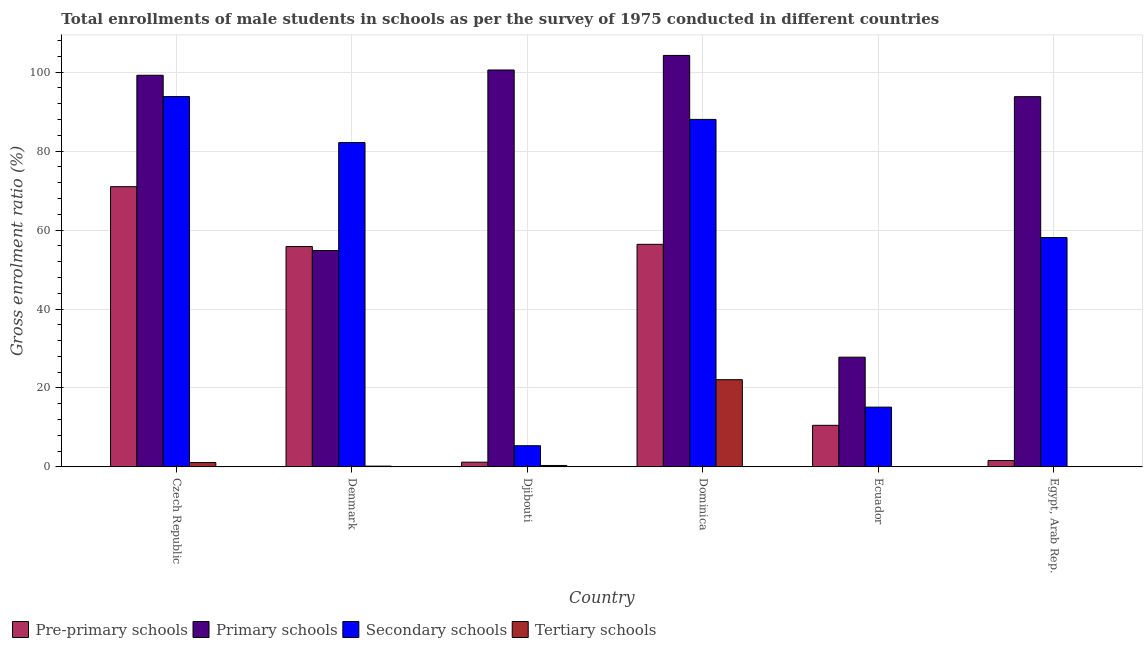How many groups of bars are there?
Ensure brevity in your answer.  6. Are the number of bars per tick equal to the number of legend labels?
Ensure brevity in your answer.  Yes. Are the number of bars on each tick of the X-axis equal?
Ensure brevity in your answer.  Yes. How many bars are there on the 6th tick from the left?
Provide a short and direct response. 4. How many bars are there on the 4th tick from the right?
Provide a succinct answer. 4. What is the label of the 6th group of bars from the left?
Provide a succinct answer. Egypt, Arab Rep. In how many cases, is the number of bars for a given country not equal to the number of legend labels?
Keep it short and to the point. 0. What is the gross enrolment ratio(male) in secondary schools in Ecuador?
Give a very brief answer. 15.14. Across all countries, what is the maximum gross enrolment ratio(male) in primary schools?
Provide a succinct answer. 104.23. Across all countries, what is the minimum gross enrolment ratio(male) in secondary schools?
Your answer should be very brief. 5.37. In which country was the gross enrolment ratio(male) in secondary schools maximum?
Give a very brief answer. Czech Republic. In which country was the gross enrolment ratio(male) in primary schools minimum?
Provide a short and direct response. Ecuador. What is the total gross enrolment ratio(male) in secondary schools in the graph?
Provide a short and direct response. 342.6. What is the difference between the gross enrolment ratio(male) in pre-primary schools in Czech Republic and that in Dominica?
Your answer should be compact. 14.6. What is the difference between the gross enrolment ratio(male) in secondary schools in Denmark and the gross enrolment ratio(male) in pre-primary schools in Egypt, Arab Rep.?
Offer a terse response. 80.54. What is the average gross enrolment ratio(male) in primary schools per country?
Make the answer very short. 80.06. What is the difference between the gross enrolment ratio(male) in tertiary schools and gross enrolment ratio(male) in primary schools in Denmark?
Ensure brevity in your answer.  -54.61. What is the ratio of the gross enrolment ratio(male) in tertiary schools in Czech Republic to that in Ecuador?
Your answer should be very brief. 27.06. What is the difference between the highest and the second highest gross enrolment ratio(male) in tertiary schools?
Your response must be concise. 20.98. What is the difference between the highest and the lowest gross enrolment ratio(male) in primary schools?
Make the answer very short. 76.43. Is the sum of the gross enrolment ratio(male) in secondary schools in Czech Republic and Dominica greater than the maximum gross enrolment ratio(male) in pre-primary schools across all countries?
Your answer should be compact. Yes. Is it the case that in every country, the sum of the gross enrolment ratio(male) in tertiary schools and gross enrolment ratio(male) in primary schools is greater than the sum of gross enrolment ratio(male) in secondary schools and gross enrolment ratio(male) in pre-primary schools?
Your response must be concise. No. What does the 2nd bar from the left in Ecuador represents?
Offer a terse response. Primary schools. What does the 3rd bar from the right in Dominica represents?
Ensure brevity in your answer.  Primary schools. How many countries are there in the graph?
Your response must be concise. 6. What is the difference between two consecutive major ticks on the Y-axis?
Your answer should be very brief. 20. Are the values on the major ticks of Y-axis written in scientific E-notation?
Provide a succinct answer. No. Does the graph contain grids?
Provide a short and direct response. Yes. How many legend labels are there?
Offer a very short reply. 4. How are the legend labels stacked?
Make the answer very short. Horizontal. What is the title of the graph?
Provide a succinct answer. Total enrollments of male students in schools as per the survey of 1975 conducted in different countries. Does "Finland" appear as one of the legend labels in the graph?
Keep it short and to the point. No. What is the label or title of the Y-axis?
Provide a short and direct response. Gross enrolment ratio (%). What is the Gross enrolment ratio (%) in Pre-primary schools in Czech Republic?
Your response must be concise. 70.99. What is the Gross enrolment ratio (%) in Primary schools in Czech Republic?
Make the answer very short. 99.21. What is the Gross enrolment ratio (%) in Secondary schools in Czech Republic?
Your answer should be very brief. 93.81. What is the Gross enrolment ratio (%) in Tertiary schools in Czech Republic?
Provide a short and direct response. 1.12. What is the Gross enrolment ratio (%) of Pre-primary schools in Denmark?
Keep it short and to the point. 55.83. What is the Gross enrolment ratio (%) in Primary schools in Denmark?
Offer a very short reply. 54.82. What is the Gross enrolment ratio (%) in Secondary schools in Denmark?
Your answer should be compact. 82.16. What is the Gross enrolment ratio (%) of Tertiary schools in Denmark?
Your answer should be very brief. 0.21. What is the Gross enrolment ratio (%) in Pre-primary schools in Djibouti?
Provide a succinct answer. 1.2. What is the Gross enrolment ratio (%) of Primary schools in Djibouti?
Keep it short and to the point. 100.54. What is the Gross enrolment ratio (%) of Secondary schools in Djibouti?
Make the answer very short. 5.37. What is the Gross enrolment ratio (%) in Tertiary schools in Djibouti?
Your response must be concise. 0.37. What is the Gross enrolment ratio (%) in Pre-primary schools in Dominica?
Offer a terse response. 56.39. What is the Gross enrolment ratio (%) of Primary schools in Dominica?
Provide a short and direct response. 104.23. What is the Gross enrolment ratio (%) of Secondary schools in Dominica?
Your response must be concise. 88.03. What is the Gross enrolment ratio (%) of Tertiary schools in Dominica?
Your answer should be very brief. 22.1. What is the Gross enrolment ratio (%) in Pre-primary schools in Ecuador?
Provide a succinct answer. 10.54. What is the Gross enrolment ratio (%) of Primary schools in Ecuador?
Your response must be concise. 27.8. What is the Gross enrolment ratio (%) in Secondary schools in Ecuador?
Offer a very short reply. 15.14. What is the Gross enrolment ratio (%) in Tertiary schools in Ecuador?
Give a very brief answer. 0.04. What is the Gross enrolment ratio (%) of Pre-primary schools in Egypt, Arab Rep.?
Provide a succinct answer. 1.61. What is the Gross enrolment ratio (%) in Primary schools in Egypt, Arab Rep.?
Provide a succinct answer. 93.79. What is the Gross enrolment ratio (%) of Secondary schools in Egypt, Arab Rep.?
Make the answer very short. 58.09. What is the Gross enrolment ratio (%) of Tertiary schools in Egypt, Arab Rep.?
Give a very brief answer. 0.05. Across all countries, what is the maximum Gross enrolment ratio (%) of Pre-primary schools?
Give a very brief answer. 70.99. Across all countries, what is the maximum Gross enrolment ratio (%) of Primary schools?
Your answer should be compact. 104.23. Across all countries, what is the maximum Gross enrolment ratio (%) in Secondary schools?
Offer a terse response. 93.81. Across all countries, what is the maximum Gross enrolment ratio (%) of Tertiary schools?
Offer a terse response. 22.1. Across all countries, what is the minimum Gross enrolment ratio (%) of Pre-primary schools?
Give a very brief answer. 1.2. Across all countries, what is the minimum Gross enrolment ratio (%) of Primary schools?
Offer a very short reply. 27.8. Across all countries, what is the minimum Gross enrolment ratio (%) in Secondary schools?
Provide a succinct answer. 5.37. Across all countries, what is the minimum Gross enrolment ratio (%) of Tertiary schools?
Offer a very short reply. 0.04. What is the total Gross enrolment ratio (%) of Pre-primary schools in the graph?
Offer a very short reply. 196.56. What is the total Gross enrolment ratio (%) of Primary schools in the graph?
Your answer should be very brief. 480.38. What is the total Gross enrolment ratio (%) of Secondary schools in the graph?
Ensure brevity in your answer.  342.6. What is the total Gross enrolment ratio (%) in Tertiary schools in the graph?
Offer a very short reply. 23.89. What is the difference between the Gross enrolment ratio (%) in Pre-primary schools in Czech Republic and that in Denmark?
Your answer should be very brief. 15.16. What is the difference between the Gross enrolment ratio (%) in Primary schools in Czech Republic and that in Denmark?
Provide a succinct answer. 44.4. What is the difference between the Gross enrolment ratio (%) of Secondary schools in Czech Republic and that in Denmark?
Give a very brief answer. 11.65. What is the difference between the Gross enrolment ratio (%) of Tertiary schools in Czech Republic and that in Denmark?
Ensure brevity in your answer.  0.91. What is the difference between the Gross enrolment ratio (%) in Pre-primary schools in Czech Republic and that in Djibouti?
Provide a short and direct response. 69.78. What is the difference between the Gross enrolment ratio (%) of Primary schools in Czech Republic and that in Djibouti?
Offer a very short reply. -1.33. What is the difference between the Gross enrolment ratio (%) of Secondary schools in Czech Republic and that in Djibouti?
Give a very brief answer. 88.43. What is the difference between the Gross enrolment ratio (%) of Tertiary schools in Czech Republic and that in Djibouti?
Give a very brief answer. 0.75. What is the difference between the Gross enrolment ratio (%) in Pre-primary schools in Czech Republic and that in Dominica?
Your response must be concise. 14.6. What is the difference between the Gross enrolment ratio (%) in Primary schools in Czech Republic and that in Dominica?
Provide a short and direct response. -5.02. What is the difference between the Gross enrolment ratio (%) of Secondary schools in Czech Republic and that in Dominica?
Your response must be concise. 5.78. What is the difference between the Gross enrolment ratio (%) in Tertiary schools in Czech Republic and that in Dominica?
Provide a succinct answer. -20.98. What is the difference between the Gross enrolment ratio (%) in Pre-primary schools in Czech Republic and that in Ecuador?
Ensure brevity in your answer.  60.45. What is the difference between the Gross enrolment ratio (%) of Primary schools in Czech Republic and that in Ecuador?
Your answer should be compact. 71.41. What is the difference between the Gross enrolment ratio (%) of Secondary schools in Czech Republic and that in Ecuador?
Offer a terse response. 78.66. What is the difference between the Gross enrolment ratio (%) of Tertiary schools in Czech Republic and that in Ecuador?
Your answer should be compact. 1.08. What is the difference between the Gross enrolment ratio (%) in Pre-primary schools in Czech Republic and that in Egypt, Arab Rep.?
Ensure brevity in your answer.  69.37. What is the difference between the Gross enrolment ratio (%) of Primary schools in Czech Republic and that in Egypt, Arab Rep.?
Provide a short and direct response. 5.42. What is the difference between the Gross enrolment ratio (%) in Secondary schools in Czech Republic and that in Egypt, Arab Rep.?
Your answer should be compact. 35.71. What is the difference between the Gross enrolment ratio (%) of Tertiary schools in Czech Republic and that in Egypt, Arab Rep.?
Keep it short and to the point. 1.06. What is the difference between the Gross enrolment ratio (%) in Pre-primary schools in Denmark and that in Djibouti?
Provide a short and direct response. 54.63. What is the difference between the Gross enrolment ratio (%) in Primary schools in Denmark and that in Djibouti?
Provide a short and direct response. -45.73. What is the difference between the Gross enrolment ratio (%) in Secondary schools in Denmark and that in Djibouti?
Provide a short and direct response. 76.78. What is the difference between the Gross enrolment ratio (%) in Tertiary schools in Denmark and that in Djibouti?
Make the answer very short. -0.16. What is the difference between the Gross enrolment ratio (%) in Pre-primary schools in Denmark and that in Dominica?
Provide a succinct answer. -0.56. What is the difference between the Gross enrolment ratio (%) in Primary schools in Denmark and that in Dominica?
Give a very brief answer. -49.41. What is the difference between the Gross enrolment ratio (%) of Secondary schools in Denmark and that in Dominica?
Ensure brevity in your answer.  -5.87. What is the difference between the Gross enrolment ratio (%) in Tertiary schools in Denmark and that in Dominica?
Offer a very short reply. -21.89. What is the difference between the Gross enrolment ratio (%) of Pre-primary schools in Denmark and that in Ecuador?
Make the answer very short. 45.29. What is the difference between the Gross enrolment ratio (%) of Primary schools in Denmark and that in Ecuador?
Ensure brevity in your answer.  27.02. What is the difference between the Gross enrolment ratio (%) in Secondary schools in Denmark and that in Ecuador?
Ensure brevity in your answer.  67.01. What is the difference between the Gross enrolment ratio (%) of Tertiary schools in Denmark and that in Ecuador?
Make the answer very short. 0.17. What is the difference between the Gross enrolment ratio (%) in Pre-primary schools in Denmark and that in Egypt, Arab Rep.?
Make the answer very short. 54.21. What is the difference between the Gross enrolment ratio (%) in Primary schools in Denmark and that in Egypt, Arab Rep.?
Provide a short and direct response. -38.97. What is the difference between the Gross enrolment ratio (%) of Secondary schools in Denmark and that in Egypt, Arab Rep.?
Your response must be concise. 24.06. What is the difference between the Gross enrolment ratio (%) of Tertiary schools in Denmark and that in Egypt, Arab Rep.?
Offer a terse response. 0.15. What is the difference between the Gross enrolment ratio (%) of Pre-primary schools in Djibouti and that in Dominica?
Your answer should be compact. -55.18. What is the difference between the Gross enrolment ratio (%) of Primary schools in Djibouti and that in Dominica?
Your answer should be very brief. -3.68. What is the difference between the Gross enrolment ratio (%) of Secondary schools in Djibouti and that in Dominica?
Give a very brief answer. -82.66. What is the difference between the Gross enrolment ratio (%) of Tertiary schools in Djibouti and that in Dominica?
Ensure brevity in your answer.  -21.73. What is the difference between the Gross enrolment ratio (%) of Pre-primary schools in Djibouti and that in Ecuador?
Keep it short and to the point. -9.34. What is the difference between the Gross enrolment ratio (%) of Primary schools in Djibouti and that in Ecuador?
Make the answer very short. 72.74. What is the difference between the Gross enrolment ratio (%) of Secondary schools in Djibouti and that in Ecuador?
Offer a very short reply. -9.77. What is the difference between the Gross enrolment ratio (%) in Tertiary schools in Djibouti and that in Ecuador?
Ensure brevity in your answer.  0.33. What is the difference between the Gross enrolment ratio (%) of Pre-primary schools in Djibouti and that in Egypt, Arab Rep.?
Your response must be concise. -0.41. What is the difference between the Gross enrolment ratio (%) of Primary schools in Djibouti and that in Egypt, Arab Rep.?
Offer a terse response. 6.76. What is the difference between the Gross enrolment ratio (%) of Secondary schools in Djibouti and that in Egypt, Arab Rep.?
Ensure brevity in your answer.  -52.72. What is the difference between the Gross enrolment ratio (%) in Tertiary schools in Djibouti and that in Egypt, Arab Rep.?
Give a very brief answer. 0.32. What is the difference between the Gross enrolment ratio (%) in Pre-primary schools in Dominica and that in Ecuador?
Offer a very short reply. 45.85. What is the difference between the Gross enrolment ratio (%) in Primary schools in Dominica and that in Ecuador?
Ensure brevity in your answer.  76.43. What is the difference between the Gross enrolment ratio (%) of Secondary schools in Dominica and that in Ecuador?
Your response must be concise. 72.88. What is the difference between the Gross enrolment ratio (%) in Tertiary schools in Dominica and that in Ecuador?
Your answer should be very brief. 22.06. What is the difference between the Gross enrolment ratio (%) of Pre-primary schools in Dominica and that in Egypt, Arab Rep.?
Provide a succinct answer. 54.77. What is the difference between the Gross enrolment ratio (%) of Primary schools in Dominica and that in Egypt, Arab Rep.?
Make the answer very short. 10.44. What is the difference between the Gross enrolment ratio (%) of Secondary schools in Dominica and that in Egypt, Arab Rep.?
Make the answer very short. 29.94. What is the difference between the Gross enrolment ratio (%) in Tertiary schools in Dominica and that in Egypt, Arab Rep.?
Provide a succinct answer. 22.05. What is the difference between the Gross enrolment ratio (%) in Pre-primary schools in Ecuador and that in Egypt, Arab Rep.?
Your answer should be very brief. 8.93. What is the difference between the Gross enrolment ratio (%) of Primary schools in Ecuador and that in Egypt, Arab Rep.?
Offer a very short reply. -65.99. What is the difference between the Gross enrolment ratio (%) in Secondary schools in Ecuador and that in Egypt, Arab Rep.?
Offer a terse response. -42.95. What is the difference between the Gross enrolment ratio (%) in Tertiary schools in Ecuador and that in Egypt, Arab Rep.?
Ensure brevity in your answer.  -0.01. What is the difference between the Gross enrolment ratio (%) in Pre-primary schools in Czech Republic and the Gross enrolment ratio (%) in Primary schools in Denmark?
Give a very brief answer. 16.17. What is the difference between the Gross enrolment ratio (%) in Pre-primary schools in Czech Republic and the Gross enrolment ratio (%) in Secondary schools in Denmark?
Provide a short and direct response. -11.17. What is the difference between the Gross enrolment ratio (%) in Pre-primary schools in Czech Republic and the Gross enrolment ratio (%) in Tertiary schools in Denmark?
Your answer should be very brief. 70.78. What is the difference between the Gross enrolment ratio (%) in Primary schools in Czech Republic and the Gross enrolment ratio (%) in Secondary schools in Denmark?
Make the answer very short. 17.06. What is the difference between the Gross enrolment ratio (%) in Primary schools in Czech Republic and the Gross enrolment ratio (%) in Tertiary schools in Denmark?
Offer a terse response. 99. What is the difference between the Gross enrolment ratio (%) in Secondary schools in Czech Republic and the Gross enrolment ratio (%) in Tertiary schools in Denmark?
Give a very brief answer. 93.6. What is the difference between the Gross enrolment ratio (%) of Pre-primary schools in Czech Republic and the Gross enrolment ratio (%) of Primary schools in Djibouti?
Provide a succinct answer. -29.56. What is the difference between the Gross enrolment ratio (%) of Pre-primary schools in Czech Republic and the Gross enrolment ratio (%) of Secondary schools in Djibouti?
Offer a very short reply. 65.61. What is the difference between the Gross enrolment ratio (%) in Pre-primary schools in Czech Republic and the Gross enrolment ratio (%) in Tertiary schools in Djibouti?
Your response must be concise. 70.62. What is the difference between the Gross enrolment ratio (%) in Primary schools in Czech Republic and the Gross enrolment ratio (%) in Secondary schools in Djibouti?
Your answer should be very brief. 93.84. What is the difference between the Gross enrolment ratio (%) of Primary schools in Czech Republic and the Gross enrolment ratio (%) of Tertiary schools in Djibouti?
Provide a short and direct response. 98.84. What is the difference between the Gross enrolment ratio (%) of Secondary schools in Czech Republic and the Gross enrolment ratio (%) of Tertiary schools in Djibouti?
Keep it short and to the point. 93.44. What is the difference between the Gross enrolment ratio (%) of Pre-primary schools in Czech Republic and the Gross enrolment ratio (%) of Primary schools in Dominica?
Provide a succinct answer. -33.24. What is the difference between the Gross enrolment ratio (%) in Pre-primary schools in Czech Republic and the Gross enrolment ratio (%) in Secondary schools in Dominica?
Ensure brevity in your answer.  -17.04. What is the difference between the Gross enrolment ratio (%) in Pre-primary schools in Czech Republic and the Gross enrolment ratio (%) in Tertiary schools in Dominica?
Your response must be concise. 48.89. What is the difference between the Gross enrolment ratio (%) in Primary schools in Czech Republic and the Gross enrolment ratio (%) in Secondary schools in Dominica?
Your answer should be very brief. 11.18. What is the difference between the Gross enrolment ratio (%) of Primary schools in Czech Republic and the Gross enrolment ratio (%) of Tertiary schools in Dominica?
Make the answer very short. 77.11. What is the difference between the Gross enrolment ratio (%) of Secondary schools in Czech Republic and the Gross enrolment ratio (%) of Tertiary schools in Dominica?
Your answer should be very brief. 71.71. What is the difference between the Gross enrolment ratio (%) in Pre-primary schools in Czech Republic and the Gross enrolment ratio (%) in Primary schools in Ecuador?
Your answer should be compact. 43.19. What is the difference between the Gross enrolment ratio (%) in Pre-primary schools in Czech Republic and the Gross enrolment ratio (%) in Secondary schools in Ecuador?
Offer a very short reply. 55.84. What is the difference between the Gross enrolment ratio (%) in Pre-primary schools in Czech Republic and the Gross enrolment ratio (%) in Tertiary schools in Ecuador?
Keep it short and to the point. 70.94. What is the difference between the Gross enrolment ratio (%) of Primary schools in Czech Republic and the Gross enrolment ratio (%) of Secondary schools in Ecuador?
Offer a terse response. 84.07. What is the difference between the Gross enrolment ratio (%) in Primary schools in Czech Republic and the Gross enrolment ratio (%) in Tertiary schools in Ecuador?
Give a very brief answer. 99.17. What is the difference between the Gross enrolment ratio (%) of Secondary schools in Czech Republic and the Gross enrolment ratio (%) of Tertiary schools in Ecuador?
Give a very brief answer. 93.76. What is the difference between the Gross enrolment ratio (%) in Pre-primary schools in Czech Republic and the Gross enrolment ratio (%) in Primary schools in Egypt, Arab Rep.?
Make the answer very short. -22.8. What is the difference between the Gross enrolment ratio (%) of Pre-primary schools in Czech Republic and the Gross enrolment ratio (%) of Secondary schools in Egypt, Arab Rep.?
Your response must be concise. 12.89. What is the difference between the Gross enrolment ratio (%) in Pre-primary schools in Czech Republic and the Gross enrolment ratio (%) in Tertiary schools in Egypt, Arab Rep.?
Provide a short and direct response. 70.93. What is the difference between the Gross enrolment ratio (%) of Primary schools in Czech Republic and the Gross enrolment ratio (%) of Secondary schools in Egypt, Arab Rep.?
Provide a succinct answer. 41.12. What is the difference between the Gross enrolment ratio (%) of Primary schools in Czech Republic and the Gross enrolment ratio (%) of Tertiary schools in Egypt, Arab Rep.?
Your answer should be compact. 99.16. What is the difference between the Gross enrolment ratio (%) of Secondary schools in Czech Republic and the Gross enrolment ratio (%) of Tertiary schools in Egypt, Arab Rep.?
Offer a very short reply. 93.75. What is the difference between the Gross enrolment ratio (%) of Pre-primary schools in Denmark and the Gross enrolment ratio (%) of Primary schools in Djibouti?
Offer a very short reply. -44.72. What is the difference between the Gross enrolment ratio (%) in Pre-primary schools in Denmark and the Gross enrolment ratio (%) in Secondary schools in Djibouti?
Ensure brevity in your answer.  50.46. What is the difference between the Gross enrolment ratio (%) in Pre-primary schools in Denmark and the Gross enrolment ratio (%) in Tertiary schools in Djibouti?
Provide a succinct answer. 55.46. What is the difference between the Gross enrolment ratio (%) of Primary schools in Denmark and the Gross enrolment ratio (%) of Secondary schools in Djibouti?
Your answer should be compact. 49.44. What is the difference between the Gross enrolment ratio (%) in Primary schools in Denmark and the Gross enrolment ratio (%) in Tertiary schools in Djibouti?
Keep it short and to the point. 54.45. What is the difference between the Gross enrolment ratio (%) of Secondary schools in Denmark and the Gross enrolment ratio (%) of Tertiary schools in Djibouti?
Provide a short and direct response. 81.79. What is the difference between the Gross enrolment ratio (%) of Pre-primary schools in Denmark and the Gross enrolment ratio (%) of Primary schools in Dominica?
Provide a succinct answer. -48.4. What is the difference between the Gross enrolment ratio (%) in Pre-primary schools in Denmark and the Gross enrolment ratio (%) in Secondary schools in Dominica?
Ensure brevity in your answer.  -32.2. What is the difference between the Gross enrolment ratio (%) in Pre-primary schools in Denmark and the Gross enrolment ratio (%) in Tertiary schools in Dominica?
Your response must be concise. 33.73. What is the difference between the Gross enrolment ratio (%) in Primary schools in Denmark and the Gross enrolment ratio (%) in Secondary schools in Dominica?
Give a very brief answer. -33.21. What is the difference between the Gross enrolment ratio (%) in Primary schools in Denmark and the Gross enrolment ratio (%) in Tertiary schools in Dominica?
Provide a short and direct response. 32.72. What is the difference between the Gross enrolment ratio (%) in Secondary schools in Denmark and the Gross enrolment ratio (%) in Tertiary schools in Dominica?
Your answer should be compact. 60.06. What is the difference between the Gross enrolment ratio (%) of Pre-primary schools in Denmark and the Gross enrolment ratio (%) of Primary schools in Ecuador?
Keep it short and to the point. 28.03. What is the difference between the Gross enrolment ratio (%) of Pre-primary schools in Denmark and the Gross enrolment ratio (%) of Secondary schools in Ecuador?
Offer a very short reply. 40.68. What is the difference between the Gross enrolment ratio (%) of Pre-primary schools in Denmark and the Gross enrolment ratio (%) of Tertiary schools in Ecuador?
Provide a short and direct response. 55.79. What is the difference between the Gross enrolment ratio (%) of Primary schools in Denmark and the Gross enrolment ratio (%) of Secondary schools in Ecuador?
Keep it short and to the point. 39.67. What is the difference between the Gross enrolment ratio (%) in Primary schools in Denmark and the Gross enrolment ratio (%) in Tertiary schools in Ecuador?
Your answer should be compact. 54.77. What is the difference between the Gross enrolment ratio (%) in Secondary schools in Denmark and the Gross enrolment ratio (%) in Tertiary schools in Ecuador?
Provide a short and direct response. 82.11. What is the difference between the Gross enrolment ratio (%) of Pre-primary schools in Denmark and the Gross enrolment ratio (%) of Primary schools in Egypt, Arab Rep.?
Your answer should be very brief. -37.96. What is the difference between the Gross enrolment ratio (%) of Pre-primary schools in Denmark and the Gross enrolment ratio (%) of Secondary schools in Egypt, Arab Rep.?
Your answer should be very brief. -2.26. What is the difference between the Gross enrolment ratio (%) of Pre-primary schools in Denmark and the Gross enrolment ratio (%) of Tertiary schools in Egypt, Arab Rep.?
Give a very brief answer. 55.77. What is the difference between the Gross enrolment ratio (%) of Primary schools in Denmark and the Gross enrolment ratio (%) of Secondary schools in Egypt, Arab Rep.?
Offer a very short reply. -3.28. What is the difference between the Gross enrolment ratio (%) in Primary schools in Denmark and the Gross enrolment ratio (%) in Tertiary schools in Egypt, Arab Rep.?
Offer a terse response. 54.76. What is the difference between the Gross enrolment ratio (%) in Secondary schools in Denmark and the Gross enrolment ratio (%) in Tertiary schools in Egypt, Arab Rep.?
Provide a short and direct response. 82.1. What is the difference between the Gross enrolment ratio (%) of Pre-primary schools in Djibouti and the Gross enrolment ratio (%) of Primary schools in Dominica?
Your answer should be very brief. -103.03. What is the difference between the Gross enrolment ratio (%) in Pre-primary schools in Djibouti and the Gross enrolment ratio (%) in Secondary schools in Dominica?
Your answer should be compact. -86.83. What is the difference between the Gross enrolment ratio (%) in Pre-primary schools in Djibouti and the Gross enrolment ratio (%) in Tertiary schools in Dominica?
Ensure brevity in your answer.  -20.9. What is the difference between the Gross enrolment ratio (%) of Primary schools in Djibouti and the Gross enrolment ratio (%) of Secondary schools in Dominica?
Provide a succinct answer. 12.52. What is the difference between the Gross enrolment ratio (%) in Primary schools in Djibouti and the Gross enrolment ratio (%) in Tertiary schools in Dominica?
Your answer should be very brief. 78.45. What is the difference between the Gross enrolment ratio (%) in Secondary schools in Djibouti and the Gross enrolment ratio (%) in Tertiary schools in Dominica?
Provide a succinct answer. -16.73. What is the difference between the Gross enrolment ratio (%) of Pre-primary schools in Djibouti and the Gross enrolment ratio (%) of Primary schools in Ecuador?
Provide a short and direct response. -26.6. What is the difference between the Gross enrolment ratio (%) of Pre-primary schools in Djibouti and the Gross enrolment ratio (%) of Secondary schools in Ecuador?
Your answer should be compact. -13.94. What is the difference between the Gross enrolment ratio (%) of Pre-primary schools in Djibouti and the Gross enrolment ratio (%) of Tertiary schools in Ecuador?
Your answer should be compact. 1.16. What is the difference between the Gross enrolment ratio (%) in Primary schools in Djibouti and the Gross enrolment ratio (%) in Secondary schools in Ecuador?
Ensure brevity in your answer.  85.4. What is the difference between the Gross enrolment ratio (%) of Primary schools in Djibouti and the Gross enrolment ratio (%) of Tertiary schools in Ecuador?
Your response must be concise. 100.5. What is the difference between the Gross enrolment ratio (%) in Secondary schools in Djibouti and the Gross enrolment ratio (%) in Tertiary schools in Ecuador?
Offer a very short reply. 5.33. What is the difference between the Gross enrolment ratio (%) in Pre-primary schools in Djibouti and the Gross enrolment ratio (%) in Primary schools in Egypt, Arab Rep.?
Your answer should be very brief. -92.59. What is the difference between the Gross enrolment ratio (%) of Pre-primary schools in Djibouti and the Gross enrolment ratio (%) of Secondary schools in Egypt, Arab Rep.?
Offer a terse response. -56.89. What is the difference between the Gross enrolment ratio (%) in Pre-primary schools in Djibouti and the Gross enrolment ratio (%) in Tertiary schools in Egypt, Arab Rep.?
Make the answer very short. 1.15. What is the difference between the Gross enrolment ratio (%) in Primary schools in Djibouti and the Gross enrolment ratio (%) in Secondary schools in Egypt, Arab Rep.?
Provide a short and direct response. 42.45. What is the difference between the Gross enrolment ratio (%) of Primary schools in Djibouti and the Gross enrolment ratio (%) of Tertiary schools in Egypt, Arab Rep.?
Your answer should be compact. 100.49. What is the difference between the Gross enrolment ratio (%) of Secondary schools in Djibouti and the Gross enrolment ratio (%) of Tertiary schools in Egypt, Arab Rep.?
Offer a very short reply. 5.32. What is the difference between the Gross enrolment ratio (%) of Pre-primary schools in Dominica and the Gross enrolment ratio (%) of Primary schools in Ecuador?
Your response must be concise. 28.59. What is the difference between the Gross enrolment ratio (%) of Pre-primary schools in Dominica and the Gross enrolment ratio (%) of Secondary schools in Ecuador?
Give a very brief answer. 41.24. What is the difference between the Gross enrolment ratio (%) of Pre-primary schools in Dominica and the Gross enrolment ratio (%) of Tertiary schools in Ecuador?
Your answer should be very brief. 56.34. What is the difference between the Gross enrolment ratio (%) in Primary schools in Dominica and the Gross enrolment ratio (%) in Secondary schools in Ecuador?
Offer a terse response. 89.08. What is the difference between the Gross enrolment ratio (%) of Primary schools in Dominica and the Gross enrolment ratio (%) of Tertiary schools in Ecuador?
Offer a very short reply. 104.19. What is the difference between the Gross enrolment ratio (%) in Secondary schools in Dominica and the Gross enrolment ratio (%) in Tertiary schools in Ecuador?
Offer a terse response. 87.99. What is the difference between the Gross enrolment ratio (%) of Pre-primary schools in Dominica and the Gross enrolment ratio (%) of Primary schools in Egypt, Arab Rep.?
Keep it short and to the point. -37.4. What is the difference between the Gross enrolment ratio (%) in Pre-primary schools in Dominica and the Gross enrolment ratio (%) in Secondary schools in Egypt, Arab Rep.?
Give a very brief answer. -1.71. What is the difference between the Gross enrolment ratio (%) in Pre-primary schools in Dominica and the Gross enrolment ratio (%) in Tertiary schools in Egypt, Arab Rep.?
Offer a terse response. 56.33. What is the difference between the Gross enrolment ratio (%) of Primary schools in Dominica and the Gross enrolment ratio (%) of Secondary schools in Egypt, Arab Rep.?
Your answer should be very brief. 46.14. What is the difference between the Gross enrolment ratio (%) in Primary schools in Dominica and the Gross enrolment ratio (%) in Tertiary schools in Egypt, Arab Rep.?
Give a very brief answer. 104.17. What is the difference between the Gross enrolment ratio (%) in Secondary schools in Dominica and the Gross enrolment ratio (%) in Tertiary schools in Egypt, Arab Rep.?
Ensure brevity in your answer.  87.97. What is the difference between the Gross enrolment ratio (%) of Pre-primary schools in Ecuador and the Gross enrolment ratio (%) of Primary schools in Egypt, Arab Rep.?
Your answer should be very brief. -83.25. What is the difference between the Gross enrolment ratio (%) of Pre-primary schools in Ecuador and the Gross enrolment ratio (%) of Secondary schools in Egypt, Arab Rep.?
Keep it short and to the point. -47.55. What is the difference between the Gross enrolment ratio (%) of Pre-primary schools in Ecuador and the Gross enrolment ratio (%) of Tertiary schools in Egypt, Arab Rep.?
Offer a very short reply. 10.49. What is the difference between the Gross enrolment ratio (%) of Primary schools in Ecuador and the Gross enrolment ratio (%) of Secondary schools in Egypt, Arab Rep.?
Keep it short and to the point. -30.29. What is the difference between the Gross enrolment ratio (%) in Primary schools in Ecuador and the Gross enrolment ratio (%) in Tertiary schools in Egypt, Arab Rep.?
Provide a succinct answer. 27.75. What is the difference between the Gross enrolment ratio (%) of Secondary schools in Ecuador and the Gross enrolment ratio (%) of Tertiary schools in Egypt, Arab Rep.?
Make the answer very short. 15.09. What is the average Gross enrolment ratio (%) of Pre-primary schools per country?
Keep it short and to the point. 32.76. What is the average Gross enrolment ratio (%) of Primary schools per country?
Make the answer very short. 80.06. What is the average Gross enrolment ratio (%) of Secondary schools per country?
Your answer should be compact. 57.1. What is the average Gross enrolment ratio (%) in Tertiary schools per country?
Your response must be concise. 3.98. What is the difference between the Gross enrolment ratio (%) in Pre-primary schools and Gross enrolment ratio (%) in Primary schools in Czech Republic?
Offer a very short reply. -28.23. What is the difference between the Gross enrolment ratio (%) of Pre-primary schools and Gross enrolment ratio (%) of Secondary schools in Czech Republic?
Your answer should be very brief. -22.82. What is the difference between the Gross enrolment ratio (%) of Pre-primary schools and Gross enrolment ratio (%) of Tertiary schools in Czech Republic?
Keep it short and to the point. 69.87. What is the difference between the Gross enrolment ratio (%) of Primary schools and Gross enrolment ratio (%) of Secondary schools in Czech Republic?
Make the answer very short. 5.41. What is the difference between the Gross enrolment ratio (%) of Primary schools and Gross enrolment ratio (%) of Tertiary schools in Czech Republic?
Keep it short and to the point. 98.09. What is the difference between the Gross enrolment ratio (%) in Secondary schools and Gross enrolment ratio (%) in Tertiary schools in Czech Republic?
Provide a succinct answer. 92.69. What is the difference between the Gross enrolment ratio (%) of Pre-primary schools and Gross enrolment ratio (%) of Primary schools in Denmark?
Your answer should be compact. 1.01. What is the difference between the Gross enrolment ratio (%) in Pre-primary schools and Gross enrolment ratio (%) in Secondary schools in Denmark?
Keep it short and to the point. -26.33. What is the difference between the Gross enrolment ratio (%) in Pre-primary schools and Gross enrolment ratio (%) in Tertiary schools in Denmark?
Ensure brevity in your answer.  55.62. What is the difference between the Gross enrolment ratio (%) in Primary schools and Gross enrolment ratio (%) in Secondary schools in Denmark?
Offer a terse response. -27.34. What is the difference between the Gross enrolment ratio (%) of Primary schools and Gross enrolment ratio (%) of Tertiary schools in Denmark?
Ensure brevity in your answer.  54.61. What is the difference between the Gross enrolment ratio (%) in Secondary schools and Gross enrolment ratio (%) in Tertiary schools in Denmark?
Offer a terse response. 81.95. What is the difference between the Gross enrolment ratio (%) of Pre-primary schools and Gross enrolment ratio (%) of Primary schools in Djibouti?
Keep it short and to the point. -99.34. What is the difference between the Gross enrolment ratio (%) in Pre-primary schools and Gross enrolment ratio (%) in Secondary schools in Djibouti?
Make the answer very short. -4.17. What is the difference between the Gross enrolment ratio (%) in Pre-primary schools and Gross enrolment ratio (%) in Tertiary schools in Djibouti?
Make the answer very short. 0.83. What is the difference between the Gross enrolment ratio (%) in Primary schools and Gross enrolment ratio (%) in Secondary schools in Djibouti?
Provide a succinct answer. 95.17. What is the difference between the Gross enrolment ratio (%) of Primary schools and Gross enrolment ratio (%) of Tertiary schools in Djibouti?
Your response must be concise. 100.18. What is the difference between the Gross enrolment ratio (%) in Secondary schools and Gross enrolment ratio (%) in Tertiary schools in Djibouti?
Provide a short and direct response. 5. What is the difference between the Gross enrolment ratio (%) of Pre-primary schools and Gross enrolment ratio (%) of Primary schools in Dominica?
Ensure brevity in your answer.  -47.84. What is the difference between the Gross enrolment ratio (%) of Pre-primary schools and Gross enrolment ratio (%) of Secondary schools in Dominica?
Provide a succinct answer. -31.64. What is the difference between the Gross enrolment ratio (%) in Pre-primary schools and Gross enrolment ratio (%) in Tertiary schools in Dominica?
Keep it short and to the point. 34.29. What is the difference between the Gross enrolment ratio (%) of Primary schools and Gross enrolment ratio (%) of Secondary schools in Dominica?
Your response must be concise. 16.2. What is the difference between the Gross enrolment ratio (%) of Primary schools and Gross enrolment ratio (%) of Tertiary schools in Dominica?
Your answer should be compact. 82.13. What is the difference between the Gross enrolment ratio (%) in Secondary schools and Gross enrolment ratio (%) in Tertiary schools in Dominica?
Provide a short and direct response. 65.93. What is the difference between the Gross enrolment ratio (%) of Pre-primary schools and Gross enrolment ratio (%) of Primary schools in Ecuador?
Offer a very short reply. -17.26. What is the difference between the Gross enrolment ratio (%) in Pre-primary schools and Gross enrolment ratio (%) in Secondary schools in Ecuador?
Give a very brief answer. -4.6. What is the difference between the Gross enrolment ratio (%) in Pre-primary schools and Gross enrolment ratio (%) in Tertiary schools in Ecuador?
Provide a short and direct response. 10.5. What is the difference between the Gross enrolment ratio (%) in Primary schools and Gross enrolment ratio (%) in Secondary schools in Ecuador?
Give a very brief answer. 12.66. What is the difference between the Gross enrolment ratio (%) of Primary schools and Gross enrolment ratio (%) of Tertiary schools in Ecuador?
Provide a short and direct response. 27.76. What is the difference between the Gross enrolment ratio (%) in Secondary schools and Gross enrolment ratio (%) in Tertiary schools in Ecuador?
Provide a short and direct response. 15.1. What is the difference between the Gross enrolment ratio (%) of Pre-primary schools and Gross enrolment ratio (%) of Primary schools in Egypt, Arab Rep.?
Offer a very short reply. -92.17. What is the difference between the Gross enrolment ratio (%) in Pre-primary schools and Gross enrolment ratio (%) in Secondary schools in Egypt, Arab Rep.?
Your answer should be very brief. -56.48. What is the difference between the Gross enrolment ratio (%) in Pre-primary schools and Gross enrolment ratio (%) in Tertiary schools in Egypt, Arab Rep.?
Provide a short and direct response. 1.56. What is the difference between the Gross enrolment ratio (%) of Primary schools and Gross enrolment ratio (%) of Secondary schools in Egypt, Arab Rep.?
Provide a succinct answer. 35.7. What is the difference between the Gross enrolment ratio (%) of Primary schools and Gross enrolment ratio (%) of Tertiary schools in Egypt, Arab Rep.?
Keep it short and to the point. 93.73. What is the difference between the Gross enrolment ratio (%) in Secondary schools and Gross enrolment ratio (%) in Tertiary schools in Egypt, Arab Rep.?
Keep it short and to the point. 58.04. What is the ratio of the Gross enrolment ratio (%) of Pre-primary schools in Czech Republic to that in Denmark?
Give a very brief answer. 1.27. What is the ratio of the Gross enrolment ratio (%) of Primary schools in Czech Republic to that in Denmark?
Provide a succinct answer. 1.81. What is the ratio of the Gross enrolment ratio (%) in Secondary schools in Czech Republic to that in Denmark?
Your answer should be very brief. 1.14. What is the ratio of the Gross enrolment ratio (%) of Tertiary schools in Czech Republic to that in Denmark?
Provide a short and direct response. 5.39. What is the ratio of the Gross enrolment ratio (%) of Pre-primary schools in Czech Republic to that in Djibouti?
Offer a terse response. 59.09. What is the ratio of the Gross enrolment ratio (%) of Primary schools in Czech Republic to that in Djibouti?
Ensure brevity in your answer.  0.99. What is the ratio of the Gross enrolment ratio (%) in Secondary schools in Czech Republic to that in Djibouti?
Make the answer very short. 17.46. What is the ratio of the Gross enrolment ratio (%) of Tertiary schools in Czech Republic to that in Djibouti?
Make the answer very short. 3.02. What is the ratio of the Gross enrolment ratio (%) of Pre-primary schools in Czech Republic to that in Dominica?
Your answer should be very brief. 1.26. What is the ratio of the Gross enrolment ratio (%) of Primary schools in Czech Republic to that in Dominica?
Your answer should be very brief. 0.95. What is the ratio of the Gross enrolment ratio (%) in Secondary schools in Czech Republic to that in Dominica?
Make the answer very short. 1.07. What is the ratio of the Gross enrolment ratio (%) in Tertiary schools in Czech Republic to that in Dominica?
Provide a succinct answer. 0.05. What is the ratio of the Gross enrolment ratio (%) in Pre-primary schools in Czech Republic to that in Ecuador?
Your answer should be very brief. 6.73. What is the ratio of the Gross enrolment ratio (%) in Primary schools in Czech Republic to that in Ecuador?
Offer a very short reply. 3.57. What is the ratio of the Gross enrolment ratio (%) in Secondary schools in Czech Republic to that in Ecuador?
Give a very brief answer. 6.19. What is the ratio of the Gross enrolment ratio (%) of Tertiary schools in Czech Republic to that in Ecuador?
Ensure brevity in your answer.  27.06. What is the ratio of the Gross enrolment ratio (%) in Pre-primary schools in Czech Republic to that in Egypt, Arab Rep.?
Provide a succinct answer. 43.98. What is the ratio of the Gross enrolment ratio (%) of Primary schools in Czech Republic to that in Egypt, Arab Rep.?
Keep it short and to the point. 1.06. What is the ratio of the Gross enrolment ratio (%) in Secondary schools in Czech Republic to that in Egypt, Arab Rep.?
Your answer should be very brief. 1.61. What is the ratio of the Gross enrolment ratio (%) of Tertiary schools in Czech Republic to that in Egypt, Arab Rep.?
Offer a terse response. 20.64. What is the ratio of the Gross enrolment ratio (%) in Pre-primary schools in Denmark to that in Djibouti?
Your answer should be very brief. 46.47. What is the ratio of the Gross enrolment ratio (%) in Primary schools in Denmark to that in Djibouti?
Offer a very short reply. 0.55. What is the ratio of the Gross enrolment ratio (%) in Secondary schools in Denmark to that in Djibouti?
Give a very brief answer. 15.29. What is the ratio of the Gross enrolment ratio (%) in Tertiary schools in Denmark to that in Djibouti?
Your answer should be very brief. 0.56. What is the ratio of the Gross enrolment ratio (%) in Primary schools in Denmark to that in Dominica?
Your response must be concise. 0.53. What is the ratio of the Gross enrolment ratio (%) in Tertiary schools in Denmark to that in Dominica?
Keep it short and to the point. 0.01. What is the ratio of the Gross enrolment ratio (%) in Pre-primary schools in Denmark to that in Ecuador?
Provide a succinct answer. 5.3. What is the ratio of the Gross enrolment ratio (%) of Primary schools in Denmark to that in Ecuador?
Provide a succinct answer. 1.97. What is the ratio of the Gross enrolment ratio (%) of Secondary schools in Denmark to that in Ecuador?
Your answer should be compact. 5.42. What is the ratio of the Gross enrolment ratio (%) of Tertiary schools in Denmark to that in Ecuador?
Your answer should be compact. 5.02. What is the ratio of the Gross enrolment ratio (%) of Pre-primary schools in Denmark to that in Egypt, Arab Rep.?
Your answer should be very brief. 34.59. What is the ratio of the Gross enrolment ratio (%) in Primary schools in Denmark to that in Egypt, Arab Rep.?
Provide a short and direct response. 0.58. What is the ratio of the Gross enrolment ratio (%) in Secondary schools in Denmark to that in Egypt, Arab Rep.?
Keep it short and to the point. 1.41. What is the ratio of the Gross enrolment ratio (%) of Tertiary schools in Denmark to that in Egypt, Arab Rep.?
Keep it short and to the point. 3.83. What is the ratio of the Gross enrolment ratio (%) of Pre-primary schools in Djibouti to that in Dominica?
Ensure brevity in your answer.  0.02. What is the ratio of the Gross enrolment ratio (%) in Primary schools in Djibouti to that in Dominica?
Offer a terse response. 0.96. What is the ratio of the Gross enrolment ratio (%) of Secondary schools in Djibouti to that in Dominica?
Keep it short and to the point. 0.06. What is the ratio of the Gross enrolment ratio (%) in Tertiary schools in Djibouti to that in Dominica?
Make the answer very short. 0.02. What is the ratio of the Gross enrolment ratio (%) of Pre-primary schools in Djibouti to that in Ecuador?
Offer a very short reply. 0.11. What is the ratio of the Gross enrolment ratio (%) in Primary schools in Djibouti to that in Ecuador?
Ensure brevity in your answer.  3.62. What is the ratio of the Gross enrolment ratio (%) in Secondary schools in Djibouti to that in Ecuador?
Provide a succinct answer. 0.35. What is the ratio of the Gross enrolment ratio (%) of Tertiary schools in Djibouti to that in Ecuador?
Keep it short and to the point. 8.95. What is the ratio of the Gross enrolment ratio (%) in Pre-primary schools in Djibouti to that in Egypt, Arab Rep.?
Keep it short and to the point. 0.74. What is the ratio of the Gross enrolment ratio (%) of Primary schools in Djibouti to that in Egypt, Arab Rep.?
Give a very brief answer. 1.07. What is the ratio of the Gross enrolment ratio (%) of Secondary schools in Djibouti to that in Egypt, Arab Rep.?
Your answer should be compact. 0.09. What is the ratio of the Gross enrolment ratio (%) of Tertiary schools in Djibouti to that in Egypt, Arab Rep.?
Your response must be concise. 6.83. What is the ratio of the Gross enrolment ratio (%) of Pre-primary schools in Dominica to that in Ecuador?
Your answer should be compact. 5.35. What is the ratio of the Gross enrolment ratio (%) of Primary schools in Dominica to that in Ecuador?
Provide a succinct answer. 3.75. What is the ratio of the Gross enrolment ratio (%) of Secondary schools in Dominica to that in Ecuador?
Your answer should be compact. 5.81. What is the ratio of the Gross enrolment ratio (%) of Tertiary schools in Dominica to that in Ecuador?
Provide a succinct answer. 535.35. What is the ratio of the Gross enrolment ratio (%) in Pre-primary schools in Dominica to that in Egypt, Arab Rep.?
Your response must be concise. 34.94. What is the ratio of the Gross enrolment ratio (%) in Primary schools in Dominica to that in Egypt, Arab Rep.?
Ensure brevity in your answer.  1.11. What is the ratio of the Gross enrolment ratio (%) in Secondary schools in Dominica to that in Egypt, Arab Rep.?
Provide a succinct answer. 1.52. What is the ratio of the Gross enrolment ratio (%) of Tertiary schools in Dominica to that in Egypt, Arab Rep.?
Make the answer very short. 408.41. What is the ratio of the Gross enrolment ratio (%) in Pre-primary schools in Ecuador to that in Egypt, Arab Rep.?
Your answer should be compact. 6.53. What is the ratio of the Gross enrolment ratio (%) of Primary schools in Ecuador to that in Egypt, Arab Rep.?
Offer a very short reply. 0.3. What is the ratio of the Gross enrolment ratio (%) of Secondary schools in Ecuador to that in Egypt, Arab Rep.?
Ensure brevity in your answer.  0.26. What is the ratio of the Gross enrolment ratio (%) in Tertiary schools in Ecuador to that in Egypt, Arab Rep.?
Offer a terse response. 0.76. What is the difference between the highest and the second highest Gross enrolment ratio (%) of Pre-primary schools?
Provide a succinct answer. 14.6. What is the difference between the highest and the second highest Gross enrolment ratio (%) of Primary schools?
Keep it short and to the point. 3.68. What is the difference between the highest and the second highest Gross enrolment ratio (%) in Secondary schools?
Your answer should be very brief. 5.78. What is the difference between the highest and the second highest Gross enrolment ratio (%) in Tertiary schools?
Offer a terse response. 20.98. What is the difference between the highest and the lowest Gross enrolment ratio (%) of Pre-primary schools?
Provide a succinct answer. 69.78. What is the difference between the highest and the lowest Gross enrolment ratio (%) of Primary schools?
Your response must be concise. 76.43. What is the difference between the highest and the lowest Gross enrolment ratio (%) of Secondary schools?
Make the answer very short. 88.43. What is the difference between the highest and the lowest Gross enrolment ratio (%) of Tertiary schools?
Make the answer very short. 22.06. 